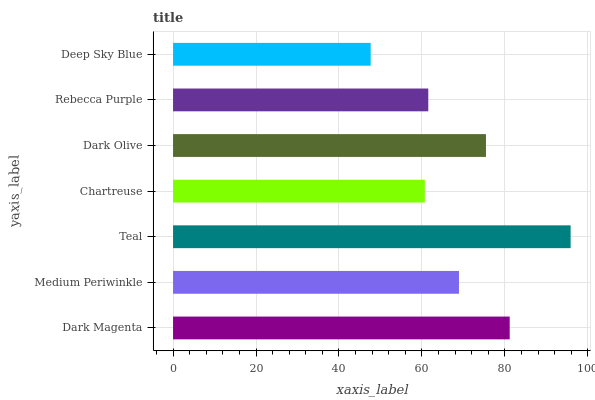Is Deep Sky Blue the minimum?
Answer yes or no. Yes. Is Teal the maximum?
Answer yes or no. Yes. Is Medium Periwinkle the minimum?
Answer yes or no. No. Is Medium Periwinkle the maximum?
Answer yes or no. No. Is Dark Magenta greater than Medium Periwinkle?
Answer yes or no. Yes. Is Medium Periwinkle less than Dark Magenta?
Answer yes or no. Yes. Is Medium Periwinkle greater than Dark Magenta?
Answer yes or no. No. Is Dark Magenta less than Medium Periwinkle?
Answer yes or no. No. Is Medium Periwinkle the high median?
Answer yes or no. Yes. Is Medium Periwinkle the low median?
Answer yes or no. Yes. Is Chartreuse the high median?
Answer yes or no. No. Is Deep Sky Blue the low median?
Answer yes or no. No. 